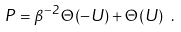<formula> <loc_0><loc_0><loc_500><loc_500>P = \beta ^ { - 2 } \, \Theta ( - U ) + \Theta ( U ) \ .</formula> 